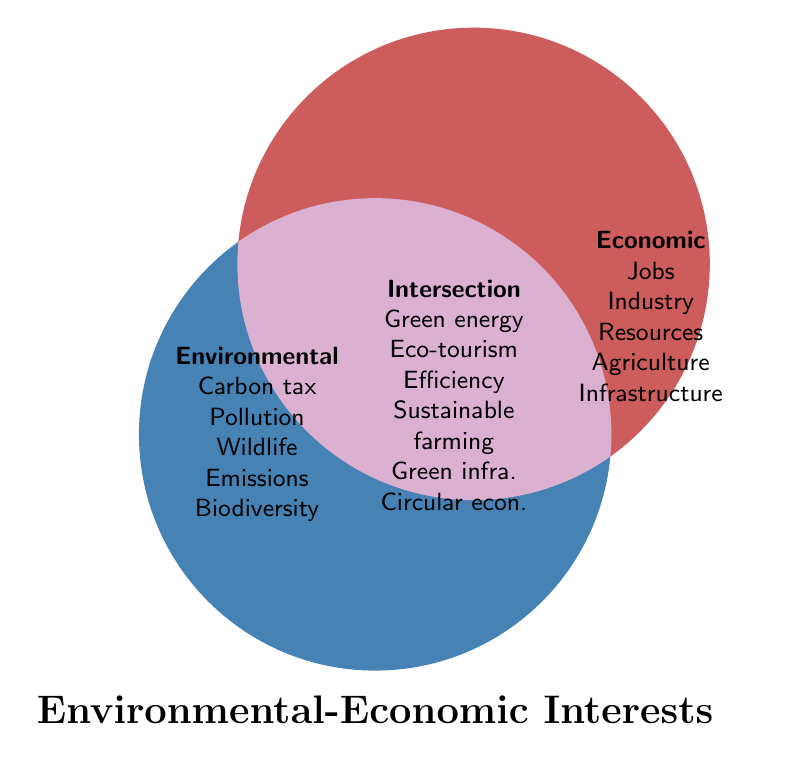What is the title of the Venn Diagram? The title is mentioned at the bottom of the diagram. It reads "Environmental-Economic Interests".
Answer: Environmental-Economic Interests Which color represents environmental interests? The color representing environmental interests is blue as indicated by the shape filled on the left side of the diagram.
Answer: Blue Name one initiative found in the intersection of environmental and economic interests. The intersection area lists several initiatives, one of which is "Green energy".
Answer: Green energy List three environmental interests shown in the diagram. The left side circle lists environmental interests which include "Carbon tax," "Pollution," and "Wildlife".
Answer: Carbon tax, Pollution, Wildlife Which economic interest is related to agricultural productivity? The right side circle contains economic interests, and "Agriculture" is highlighted as one interest related to agricultural productivity.
Answer: Agriculture How are wildlife conservation and eco-tourism connected in the diagram? Wildlife conservation is listed under environmental interests, and eco-tourism is listed in the intersection area, implying a connection between wildlife preservation and tourism benefits.
Answer: Wildlife conservation leads to eco-tourism What type of projects are found in the intersection concerning infrastructure? The intersection lists "Green infrastructure projects," indicating these projects support both environmental and economic interests.
Answer: Green infrastructure projects Which economic interest has a corresponding element in the sustainable farming practices in the intersection? Agricultural productivity is an economic interest, and the intersection contains "Sustainable farming practices," linking these two elements.
Answer: Agricultural productivity How many interests are listed under the economic category? The economic interests listed on the right side are five: "Jobs," "Industry," "Resources," "Agriculture," and "Infrastructure."
Answer: Five Compare the relationship between emissions reduction and energy efficiency measures. Emissions reduction is an environmental interest, and energy efficiency measures are listed in the intersection area, indicating emissions reductions can be achieved through energy efficiency.
Answer: Emissions reduction relates to energy efficiency measures 